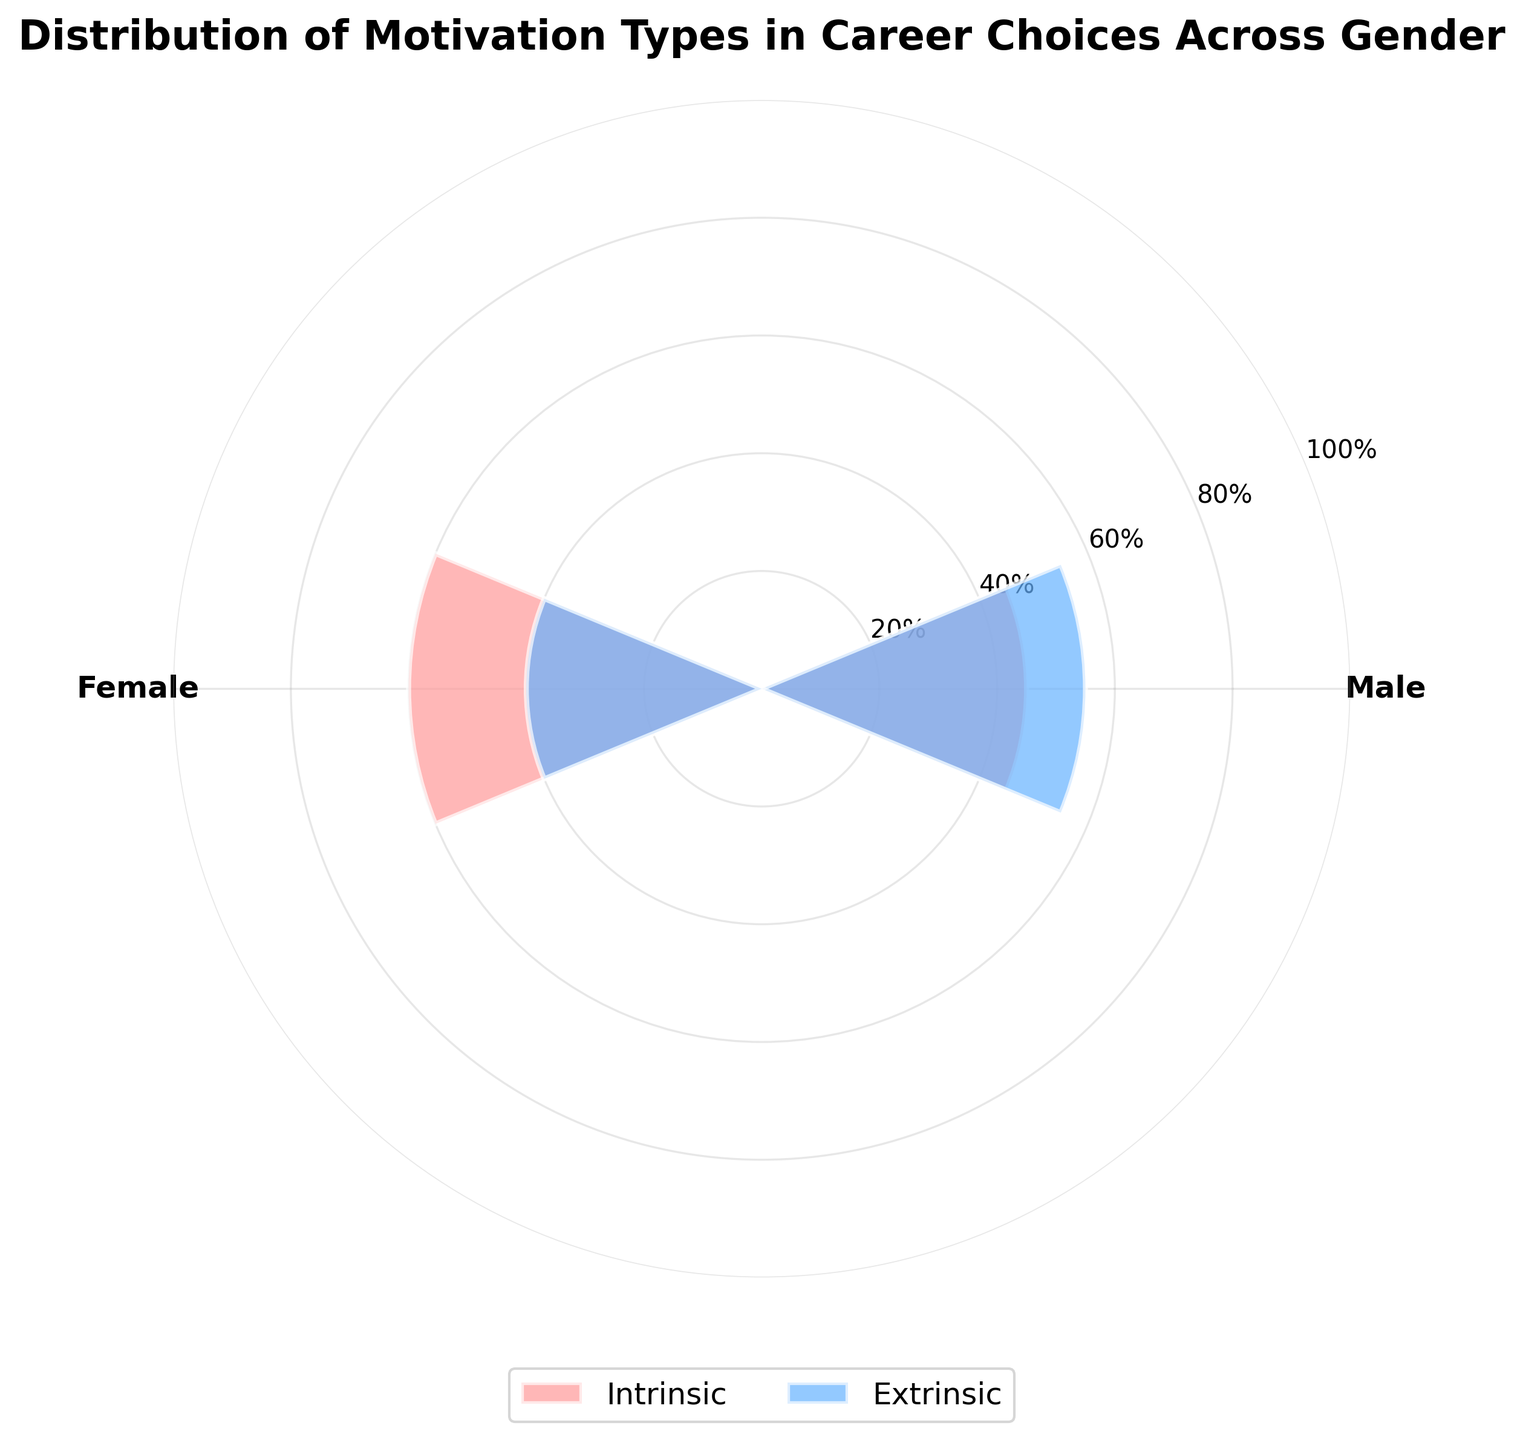What is the title of the figure? The title is usually at the top of the figure. Reading it will give us the exact wording.
Answer: Distribution of Motivation Types in Career Choices Across Gender What percentage of males have intrinsic motivation? Look at the segment labeled "Male" and check the value corresponding to "Intrinsic".
Answer: 45% Which gender has a higher percentage of intrinsic motivation? Compare the intrinsic motivation percentages for males and females by looking at the labeled segments.
Answer: Female What is the difference in extrinsic motivation percentage between males and females? Subtract the extrinsic motivation percentage of females from that of males. So, 55% (males) - 40% (females) = 15%
Answer: 15% What color represents intrinsic motivation in the chart? Identify the color of the segment labeled "Intrinsic".
Answer: Red-pinkish How many distinct motivations are displayed in the figure? Count the unique motivation types labeled in the legend or the bars themselves.
Answer: 2 How are the axes labeled in the figure? Look at the radial and polar axes to read their labels or ticks. They should typically show percentage intervals or group names.
Answer: Gender labels and percentage ticks By how much does the intrinsic motivation percentage of females exceed that of males? Subtract the intrinsic percentage of males from that of females. So, 60% (females) - 45% (males) = 15%
Answer: 15% Which gender has a lower percentage of extrinsic motivation? Compare the extrinsic motivation percentages of both genders by looking at the segments labeled "Extrinsic".
Answer: Female Considering both genders, what is the average intrinsic motivation percentage? Add the intrinsic percentages of both genders and divide by 2. So, (45% + 60%) / 2 = 52.5%
Answer: 52.5% 